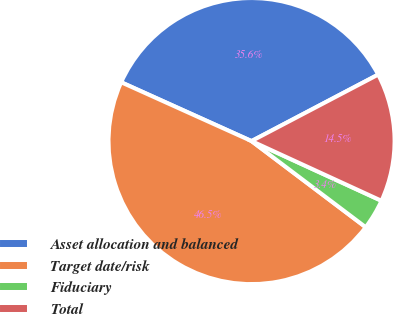<chart> <loc_0><loc_0><loc_500><loc_500><pie_chart><fcel>Asset allocation and balanced<fcel>Target date/risk<fcel>Fiduciary<fcel>Total<nl><fcel>35.56%<fcel>46.46%<fcel>3.43%<fcel>14.55%<nl></chart> 